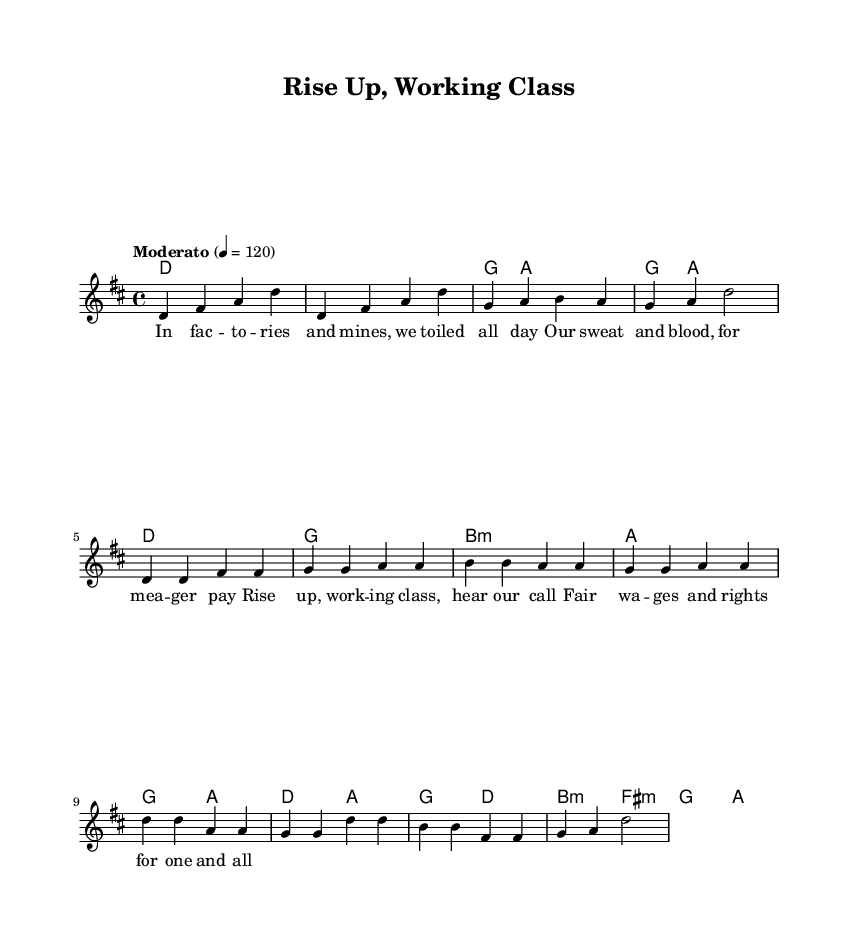What is the key signature of this music? The key signature is indicated at the beginning of the sheet music and shows two sharps, which correspond to F sharp and C sharp. This indicates the D major scale, which is evidenced by the note pitches used throughout the piece.
Answer: D major What is the time signature of this music? The time signature is located at the beginning of the sheet music, just after the key signature. It is displayed as a fraction, with 4 on top and 4 on the bottom, indicating that each measure contains four beats, and each beat is a quarter note.
Answer: 4/4 What is the tempo marking of the piece? The tempo marking is indicated in the score, next to the time signature. It specifies "Moderato" and a rhythmic value of 120 beats per minute, suggesting a moderate pace for the performance.
Answer: Moderato What type of chords are used in the chorus? By examining the harmony section, the chorus includes the chords D major, A major, B minor, and F sharp minor. These are standard chord types found in rock music, which emphasize the key signature established earlier.
Answer: D, A, B minor, F sharp minor How many phrases are there in the verse? The verse consists of a sequence of lyrical lines, typically separated by pauses in musical phrasing. By counting, there are four distinct phrases apparent in the verse, each contributing to the overall structure of the song.
Answer: 4 What is the overall theme of the lyrics? The lyrics express a clear call to action for the working class, emphasizing themes of labor rights and fair wages. This is a prominent feature in protest songs, which often advocate for social change and workers' rights.
Answer: Labor rights What kind of musical form is indicated by the structure of this sheet music? The structure is consistent with common popular music forms, specifically a verse-chorus form. The repetition of melody lines and chord progressions in a recognizable pattern indicates this form, which is typical in rock music.
Answer: Verse-chorus form 